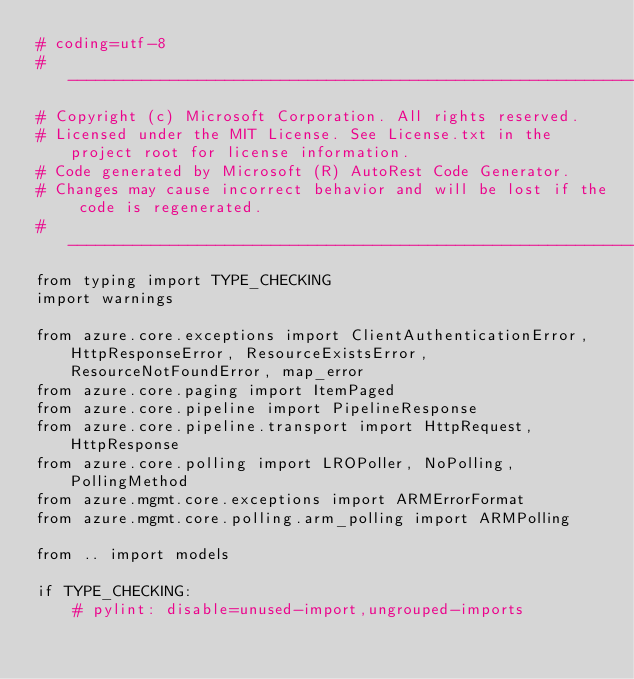Convert code to text. <code><loc_0><loc_0><loc_500><loc_500><_Python_># coding=utf-8
# --------------------------------------------------------------------------
# Copyright (c) Microsoft Corporation. All rights reserved.
# Licensed under the MIT License. See License.txt in the project root for license information.
# Code generated by Microsoft (R) AutoRest Code Generator.
# Changes may cause incorrect behavior and will be lost if the code is regenerated.
# --------------------------------------------------------------------------
from typing import TYPE_CHECKING
import warnings

from azure.core.exceptions import ClientAuthenticationError, HttpResponseError, ResourceExistsError, ResourceNotFoundError, map_error
from azure.core.paging import ItemPaged
from azure.core.pipeline import PipelineResponse
from azure.core.pipeline.transport import HttpRequest, HttpResponse
from azure.core.polling import LROPoller, NoPolling, PollingMethod
from azure.mgmt.core.exceptions import ARMErrorFormat
from azure.mgmt.core.polling.arm_polling import ARMPolling

from .. import models

if TYPE_CHECKING:
    # pylint: disable=unused-import,ungrouped-imports</code> 